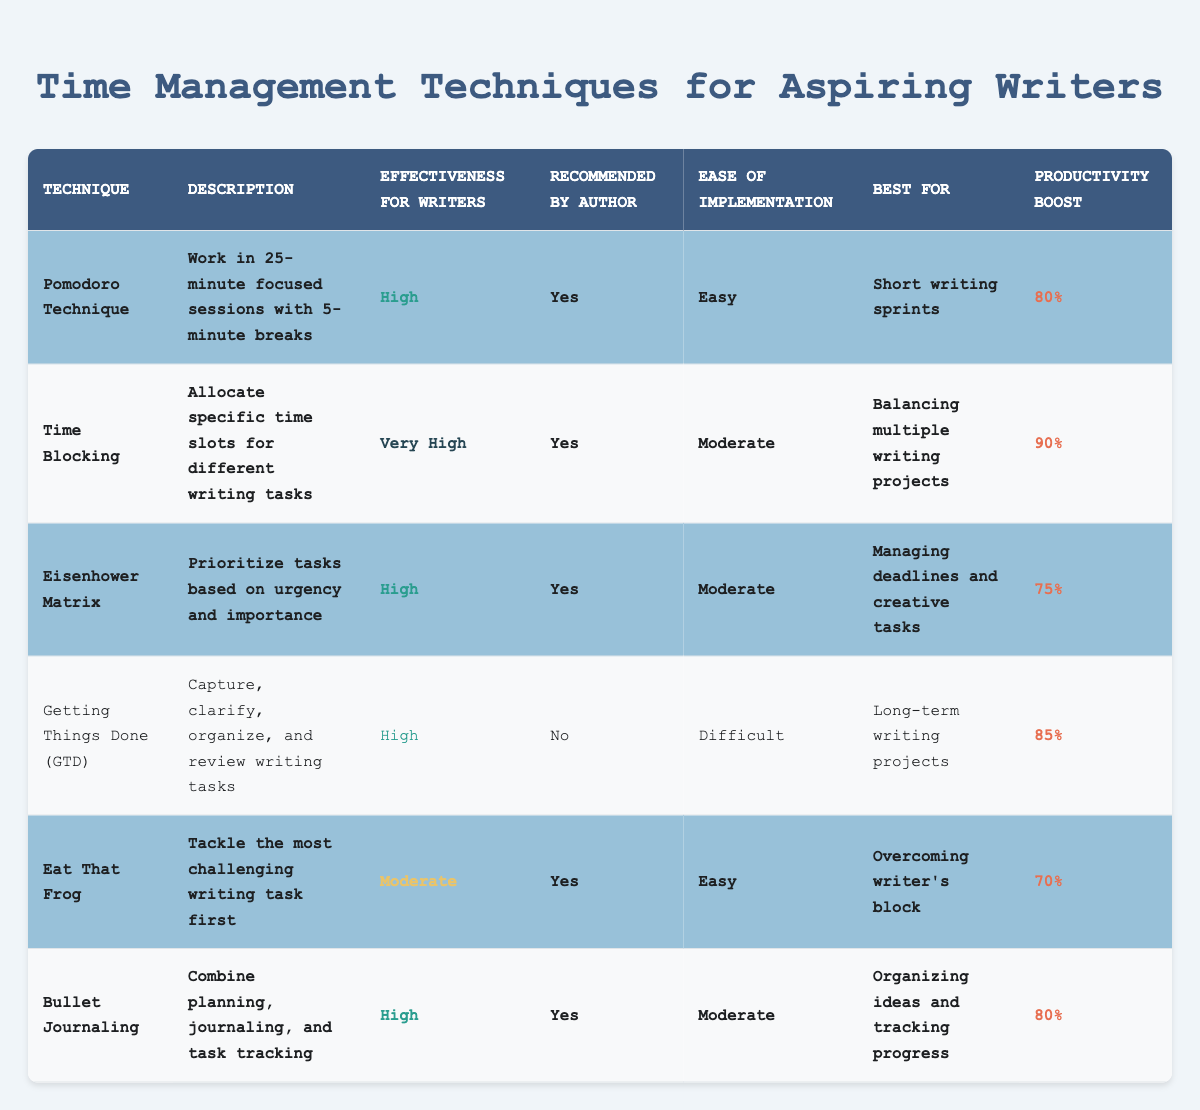What is the productivity boost percentage of the Time Blocking technique? The table shows that the Time Blocking technique has a productivity boost of 90%.
Answer: 90% Which technique has the highest effectiveness for writers? The table indicates that Time Blocking has an effectiveness for writers rating of "Very High," which is the highest compared to other techniques.
Answer: Time Blocking How many techniques are recommended by the author? By counting the 'Yes' values in the "Recommended by Author" column, we find there are five techniques that are recommended by the author.
Answer: 5 What is the average productivity boost for the techniques recommended by the author? The recommended techniques are Pomodoro (80%), Time Blocking (90%), Eisenhower Matrix (75%), Eat That Frog (70%), and Bullet Journaling (80%). To find the average, we sum these values (80 + 90 + 75 + 70 + 80 = 395) and divide by the number of techniques (5), resulting in an average of 395/5 = 79.
Answer: 79 Is the Getting Things Done technique easy to implement? The table indicates that Getting Things Done has a rating of "Difficult" in the "Ease of Implementation" column, which means it is not easy to implement.
Answer: No Which technique is the best for managing deadlines and creative tasks? The description of the Eisenhower Matrix states it is best for managing deadlines and creative tasks, making it the technique suited for this purpose.
Answer: Eisenhower Matrix What is the effectiveness rating for the Eat That Frog technique? The effectiveness rating for the Eat That Frog technique is categorized as "Moderate" in the table.
Answer: Moderate Which technique has the lowest productivity boost among the recommended techniques? By examining the productivity boost percentages of the recommended techniques, Eat That Frog has the lowest boost at 70%.
Answer: Eat That Frog 